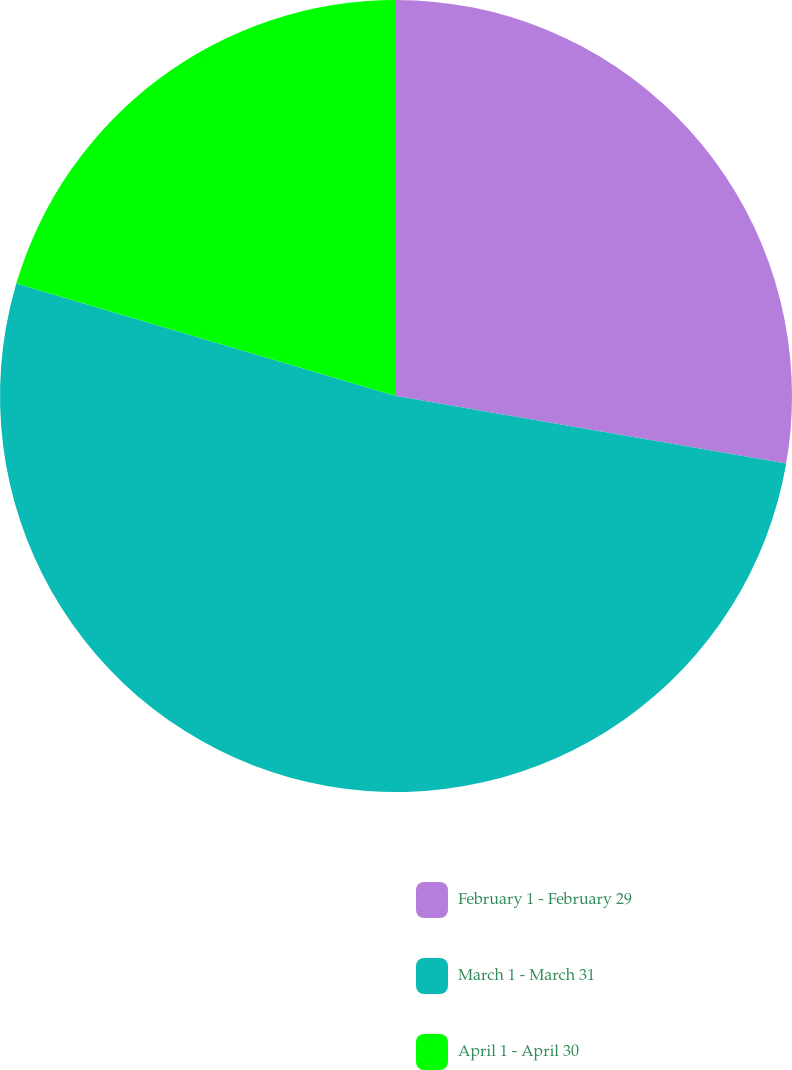Convert chart. <chart><loc_0><loc_0><loc_500><loc_500><pie_chart><fcel>February 1 - February 29<fcel>March 1 - March 31<fcel>April 1 - April 30<nl><fcel>27.73%<fcel>51.85%<fcel>20.42%<nl></chart> 